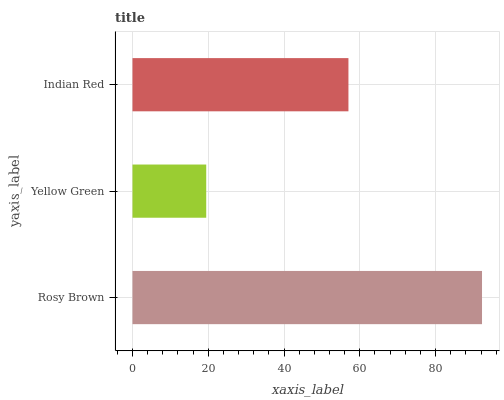Is Yellow Green the minimum?
Answer yes or no. Yes. Is Rosy Brown the maximum?
Answer yes or no. Yes. Is Indian Red the minimum?
Answer yes or no. No. Is Indian Red the maximum?
Answer yes or no. No. Is Indian Red greater than Yellow Green?
Answer yes or no. Yes. Is Yellow Green less than Indian Red?
Answer yes or no. Yes. Is Yellow Green greater than Indian Red?
Answer yes or no. No. Is Indian Red less than Yellow Green?
Answer yes or no. No. Is Indian Red the high median?
Answer yes or no. Yes. Is Indian Red the low median?
Answer yes or no. Yes. Is Rosy Brown the high median?
Answer yes or no. No. Is Rosy Brown the low median?
Answer yes or no. No. 